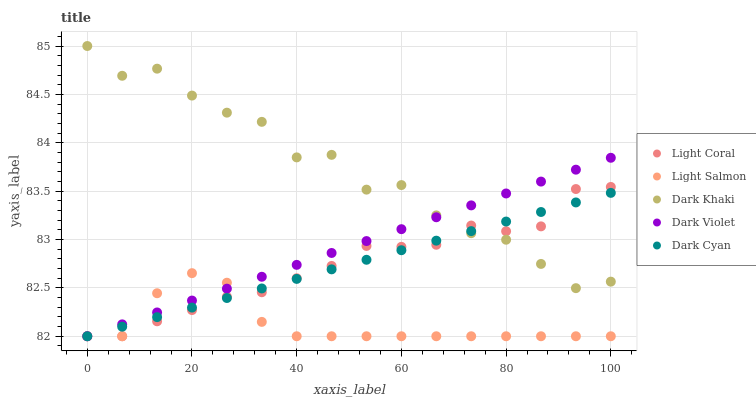Does Light Salmon have the minimum area under the curve?
Answer yes or no. Yes. Does Dark Khaki have the maximum area under the curve?
Answer yes or no. Yes. Does Dark Khaki have the minimum area under the curve?
Answer yes or no. No. Does Light Salmon have the maximum area under the curve?
Answer yes or no. No. Is Dark Violet the smoothest?
Answer yes or no. Yes. Is Dark Khaki the roughest?
Answer yes or no. Yes. Is Light Salmon the smoothest?
Answer yes or no. No. Is Light Salmon the roughest?
Answer yes or no. No. Does Light Coral have the lowest value?
Answer yes or no. Yes. Does Dark Khaki have the lowest value?
Answer yes or no. No. Does Dark Khaki have the highest value?
Answer yes or no. Yes. Does Light Salmon have the highest value?
Answer yes or no. No. Is Light Salmon less than Dark Khaki?
Answer yes or no. Yes. Is Dark Khaki greater than Light Salmon?
Answer yes or no. Yes. Does Dark Violet intersect Light Coral?
Answer yes or no. Yes. Is Dark Violet less than Light Coral?
Answer yes or no. No. Is Dark Violet greater than Light Coral?
Answer yes or no. No. Does Light Salmon intersect Dark Khaki?
Answer yes or no. No. 